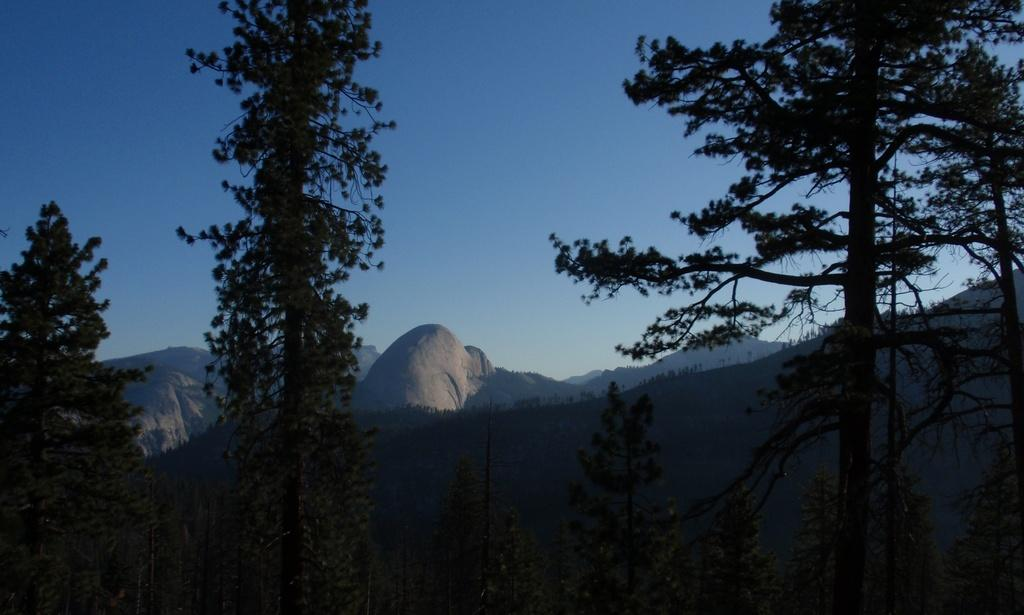What type of vegetation can be seen in the image? There are trees in the image. What can be seen in the distance behind the trees? There are hills in the background of the image. What features are present on the hills? The hills have rocks and trees. What is visible at the top of the image? The sky is visible at the top of the image. Is there an office building visible in the image? No, there is no office building present in the image. Is this a scene from a fictional story? The image does not provide any information about whether it is from a fictional story or not. 